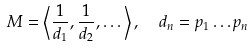Convert formula to latex. <formula><loc_0><loc_0><loc_500><loc_500>M = \left \langle \frac { 1 } { d _ { 1 } } , \frac { 1 } { d _ { 2 } } , \dots \right \rangle , \ \ d _ { n } = p _ { 1 } \dots p _ { n }</formula> 